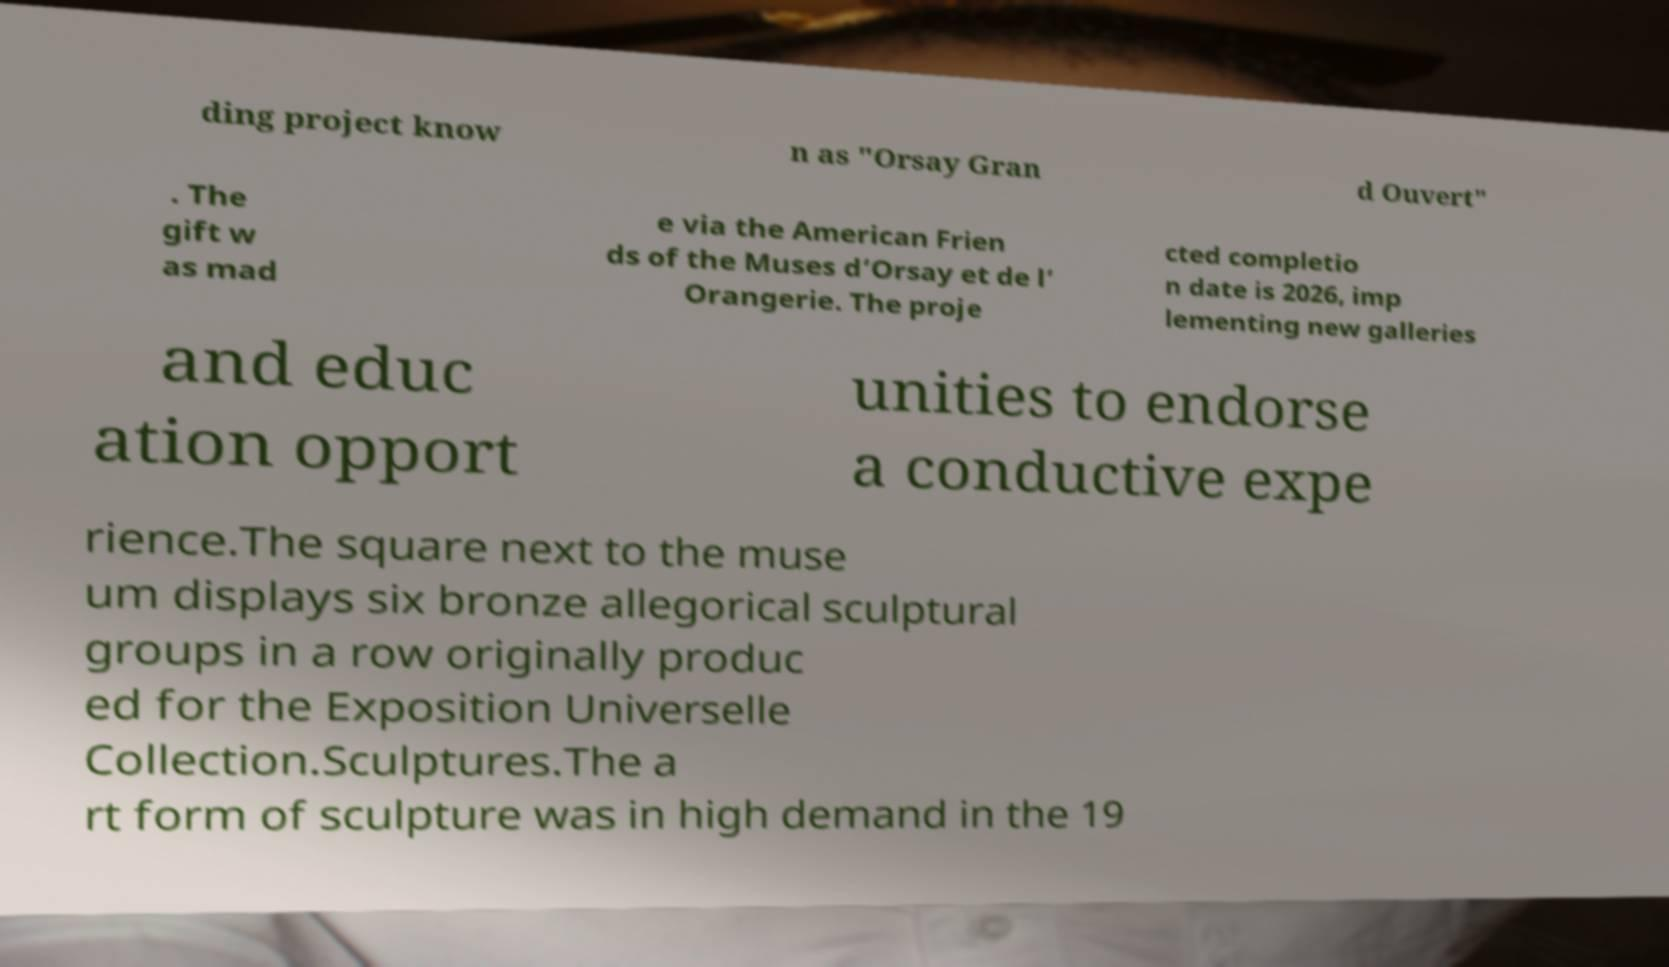Please read and relay the text visible in this image. What does it say? ding project know n as "Orsay Gran d Ouvert" . The gift w as mad e via the American Frien ds of the Muses d’Orsay et de l’ Orangerie. The proje cted completio n date is 2026, imp lementing new galleries and educ ation opport unities to endorse a conductive expe rience.The square next to the muse um displays six bronze allegorical sculptural groups in a row originally produc ed for the Exposition Universelle Collection.Sculptures.The a rt form of sculpture was in high demand in the 19 